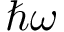Convert formula to latex. <formula><loc_0><loc_0><loc_500><loc_500>\hbar { \omega }</formula> 